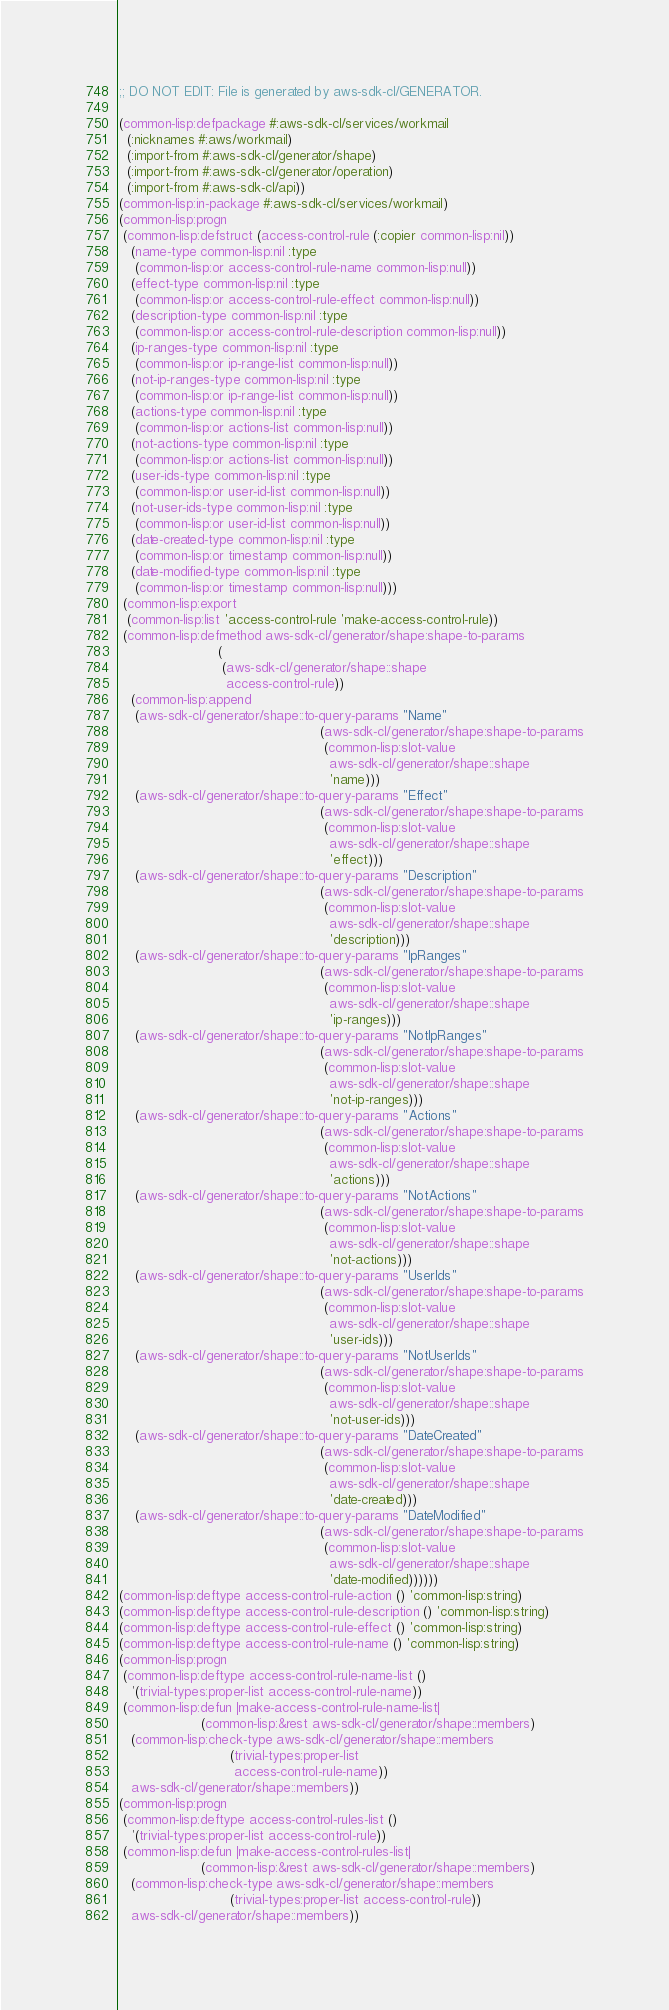Convert code to text. <code><loc_0><loc_0><loc_500><loc_500><_Lisp_>;; DO NOT EDIT: File is generated by aws-sdk-cl/GENERATOR.

(common-lisp:defpackage #:aws-sdk-cl/services/workmail
  (:nicknames #:aws/workmail)
  (:import-from #:aws-sdk-cl/generator/shape)
  (:import-from #:aws-sdk-cl/generator/operation)
  (:import-from #:aws-sdk-cl/api))
(common-lisp:in-package #:aws-sdk-cl/services/workmail)
(common-lisp:progn
 (common-lisp:defstruct (access-control-rule (:copier common-lisp:nil))
   (name-type common-lisp:nil :type
    (common-lisp:or access-control-rule-name common-lisp:null))
   (effect-type common-lisp:nil :type
    (common-lisp:or access-control-rule-effect common-lisp:null))
   (description-type common-lisp:nil :type
    (common-lisp:or access-control-rule-description common-lisp:null))
   (ip-ranges-type common-lisp:nil :type
    (common-lisp:or ip-range-list common-lisp:null))
   (not-ip-ranges-type common-lisp:nil :type
    (common-lisp:or ip-range-list common-lisp:null))
   (actions-type common-lisp:nil :type
    (common-lisp:or actions-list common-lisp:null))
   (not-actions-type common-lisp:nil :type
    (common-lisp:or actions-list common-lisp:null))
   (user-ids-type common-lisp:nil :type
    (common-lisp:or user-id-list common-lisp:null))
   (not-user-ids-type common-lisp:nil :type
    (common-lisp:or user-id-list common-lisp:null))
   (date-created-type common-lisp:nil :type
    (common-lisp:or timestamp common-lisp:null))
   (date-modified-type common-lisp:nil :type
    (common-lisp:or timestamp common-lisp:null)))
 (common-lisp:export
  (common-lisp:list 'access-control-rule 'make-access-control-rule))
 (common-lisp:defmethod aws-sdk-cl/generator/shape:shape-to-params
                        (
                         (aws-sdk-cl/generator/shape::shape
                          access-control-rule))
   (common-lisp:append
    (aws-sdk-cl/generator/shape::to-query-params "Name"
                                                 (aws-sdk-cl/generator/shape:shape-to-params
                                                  (common-lisp:slot-value
                                                   aws-sdk-cl/generator/shape::shape
                                                   'name)))
    (aws-sdk-cl/generator/shape::to-query-params "Effect"
                                                 (aws-sdk-cl/generator/shape:shape-to-params
                                                  (common-lisp:slot-value
                                                   aws-sdk-cl/generator/shape::shape
                                                   'effect)))
    (aws-sdk-cl/generator/shape::to-query-params "Description"
                                                 (aws-sdk-cl/generator/shape:shape-to-params
                                                  (common-lisp:slot-value
                                                   aws-sdk-cl/generator/shape::shape
                                                   'description)))
    (aws-sdk-cl/generator/shape::to-query-params "IpRanges"
                                                 (aws-sdk-cl/generator/shape:shape-to-params
                                                  (common-lisp:slot-value
                                                   aws-sdk-cl/generator/shape::shape
                                                   'ip-ranges)))
    (aws-sdk-cl/generator/shape::to-query-params "NotIpRanges"
                                                 (aws-sdk-cl/generator/shape:shape-to-params
                                                  (common-lisp:slot-value
                                                   aws-sdk-cl/generator/shape::shape
                                                   'not-ip-ranges)))
    (aws-sdk-cl/generator/shape::to-query-params "Actions"
                                                 (aws-sdk-cl/generator/shape:shape-to-params
                                                  (common-lisp:slot-value
                                                   aws-sdk-cl/generator/shape::shape
                                                   'actions)))
    (aws-sdk-cl/generator/shape::to-query-params "NotActions"
                                                 (aws-sdk-cl/generator/shape:shape-to-params
                                                  (common-lisp:slot-value
                                                   aws-sdk-cl/generator/shape::shape
                                                   'not-actions)))
    (aws-sdk-cl/generator/shape::to-query-params "UserIds"
                                                 (aws-sdk-cl/generator/shape:shape-to-params
                                                  (common-lisp:slot-value
                                                   aws-sdk-cl/generator/shape::shape
                                                   'user-ids)))
    (aws-sdk-cl/generator/shape::to-query-params "NotUserIds"
                                                 (aws-sdk-cl/generator/shape:shape-to-params
                                                  (common-lisp:slot-value
                                                   aws-sdk-cl/generator/shape::shape
                                                   'not-user-ids)))
    (aws-sdk-cl/generator/shape::to-query-params "DateCreated"
                                                 (aws-sdk-cl/generator/shape:shape-to-params
                                                  (common-lisp:slot-value
                                                   aws-sdk-cl/generator/shape::shape
                                                   'date-created)))
    (aws-sdk-cl/generator/shape::to-query-params "DateModified"
                                                 (aws-sdk-cl/generator/shape:shape-to-params
                                                  (common-lisp:slot-value
                                                   aws-sdk-cl/generator/shape::shape
                                                   'date-modified))))))
(common-lisp:deftype access-control-rule-action () 'common-lisp:string)
(common-lisp:deftype access-control-rule-description () 'common-lisp:string)
(common-lisp:deftype access-control-rule-effect () 'common-lisp:string)
(common-lisp:deftype access-control-rule-name () 'common-lisp:string)
(common-lisp:progn
 (common-lisp:deftype access-control-rule-name-list ()
   '(trivial-types:proper-list access-control-rule-name))
 (common-lisp:defun |make-access-control-rule-name-list|
                    (common-lisp:&rest aws-sdk-cl/generator/shape::members)
   (common-lisp:check-type aws-sdk-cl/generator/shape::members
                           (trivial-types:proper-list
                            access-control-rule-name))
   aws-sdk-cl/generator/shape::members))
(common-lisp:progn
 (common-lisp:deftype access-control-rules-list ()
   '(trivial-types:proper-list access-control-rule))
 (common-lisp:defun |make-access-control-rules-list|
                    (common-lisp:&rest aws-sdk-cl/generator/shape::members)
   (common-lisp:check-type aws-sdk-cl/generator/shape::members
                           (trivial-types:proper-list access-control-rule))
   aws-sdk-cl/generator/shape::members))</code> 